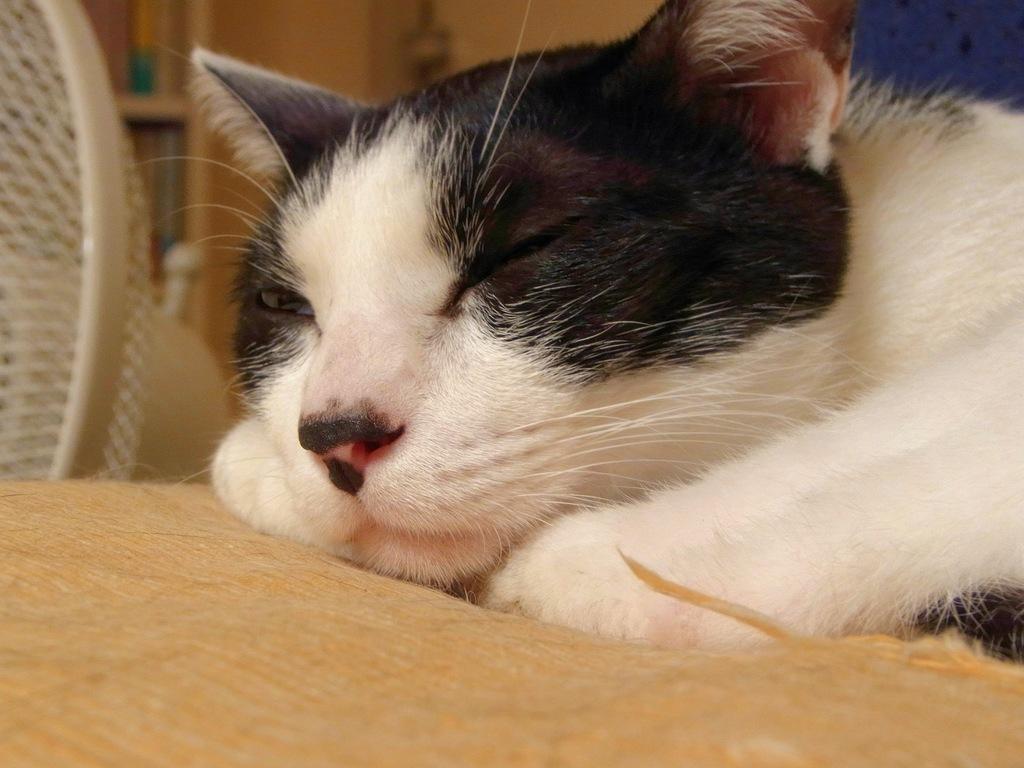Please provide a concise description of this image. In this image I can see a white cat sleeping on a cushion with a blur background. 